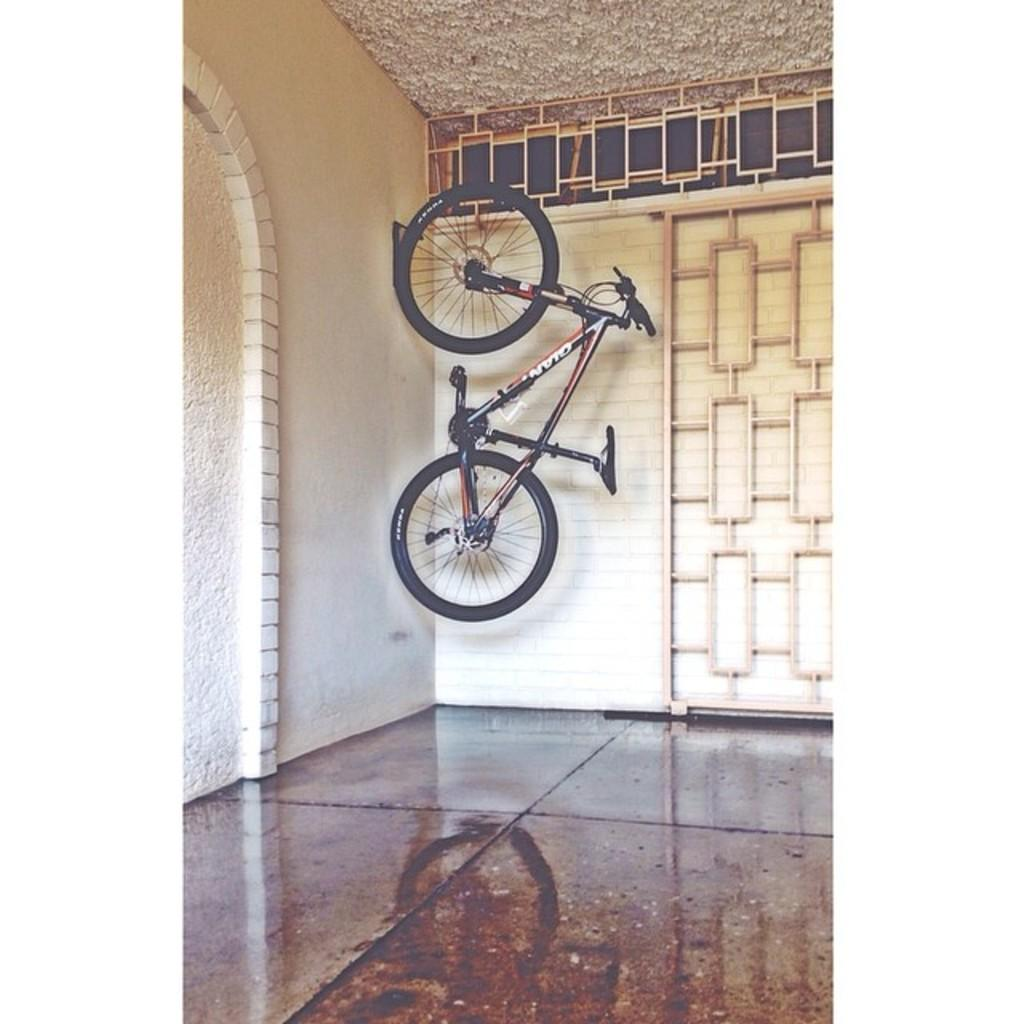What is the main object in the image? There is a cycle in the image. Where is the cycle located? The cycle is hanged on the wall. What can be seen behind the cycle? There is a wall visible in the image. What architectural feature is present in the image? There is a railing in the image. What type of prose is being recited by the achiever standing on the mountain in the image? There is no achiever, mountain, or prose present in the image. 